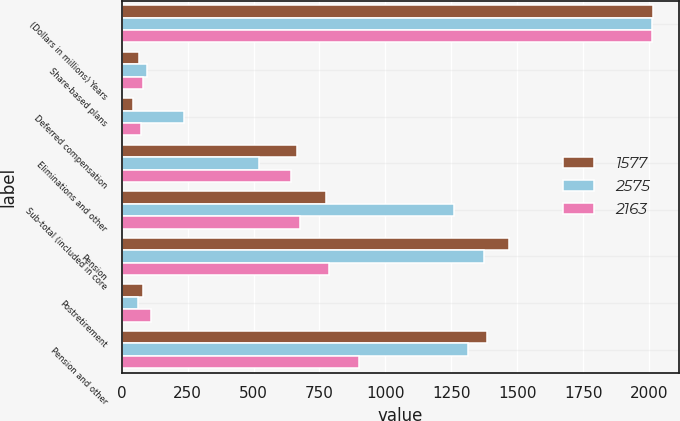Convert chart. <chart><loc_0><loc_0><loc_500><loc_500><stacked_bar_chart><ecel><fcel>(Dollars in millions) Years<fcel>Share-based plans<fcel>Deferred compensation<fcel>Eliminations and other<fcel>Sub-total (included in core<fcel>Pension<fcel>Postretirement<fcel>Pension and other<nl><fcel>1577<fcel>2014<fcel>67<fcel>44<fcel>665<fcel>776<fcel>1469<fcel>82<fcel>1387<nl><fcel>2575<fcel>2013<fcel>95<fcel>238<fcel>522<fcel>1261<fcel>1374<fcel>60<fcel>1314<nl><fcel>2163<fcel>2012<fcel>81<fcel>75<fcel>643<fcel>678<fcel>787<fcel>112<fcel>899<nl></chart> 